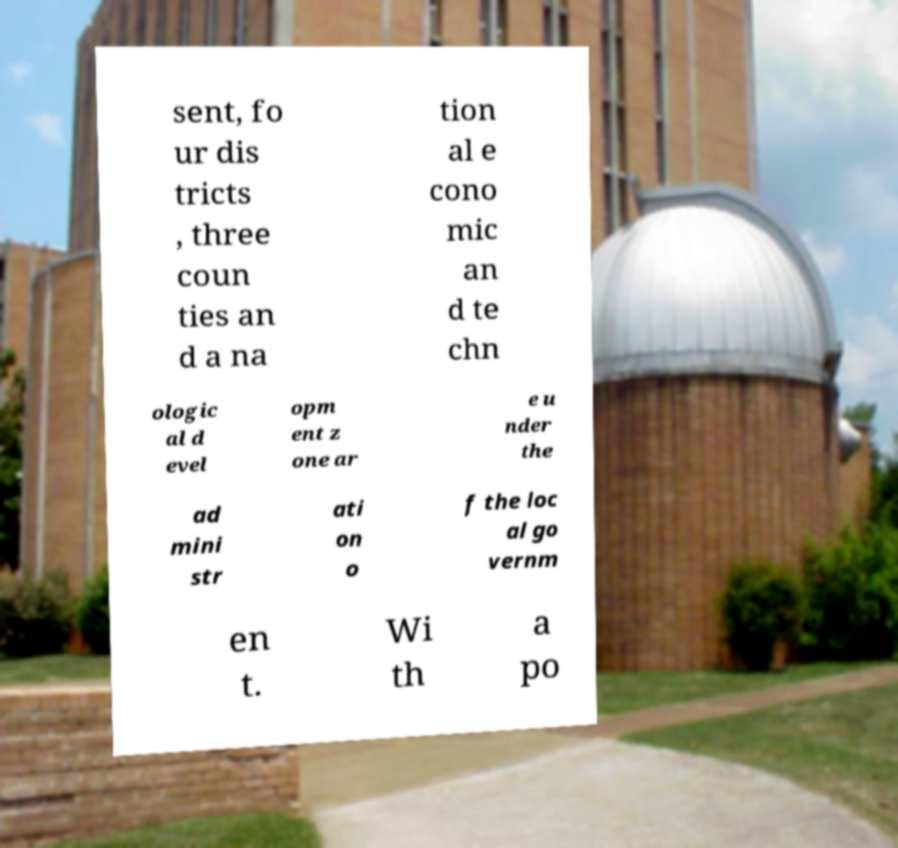Could you extract and type out the text from this image? sent, fo ur dis tricts , three coun ties an d a na tion al e cono mic an d te chn ologic al d evel opm ent z one ar e u nder the ad mini str ati on o f the loc al go vernm en t. Wi th a po 